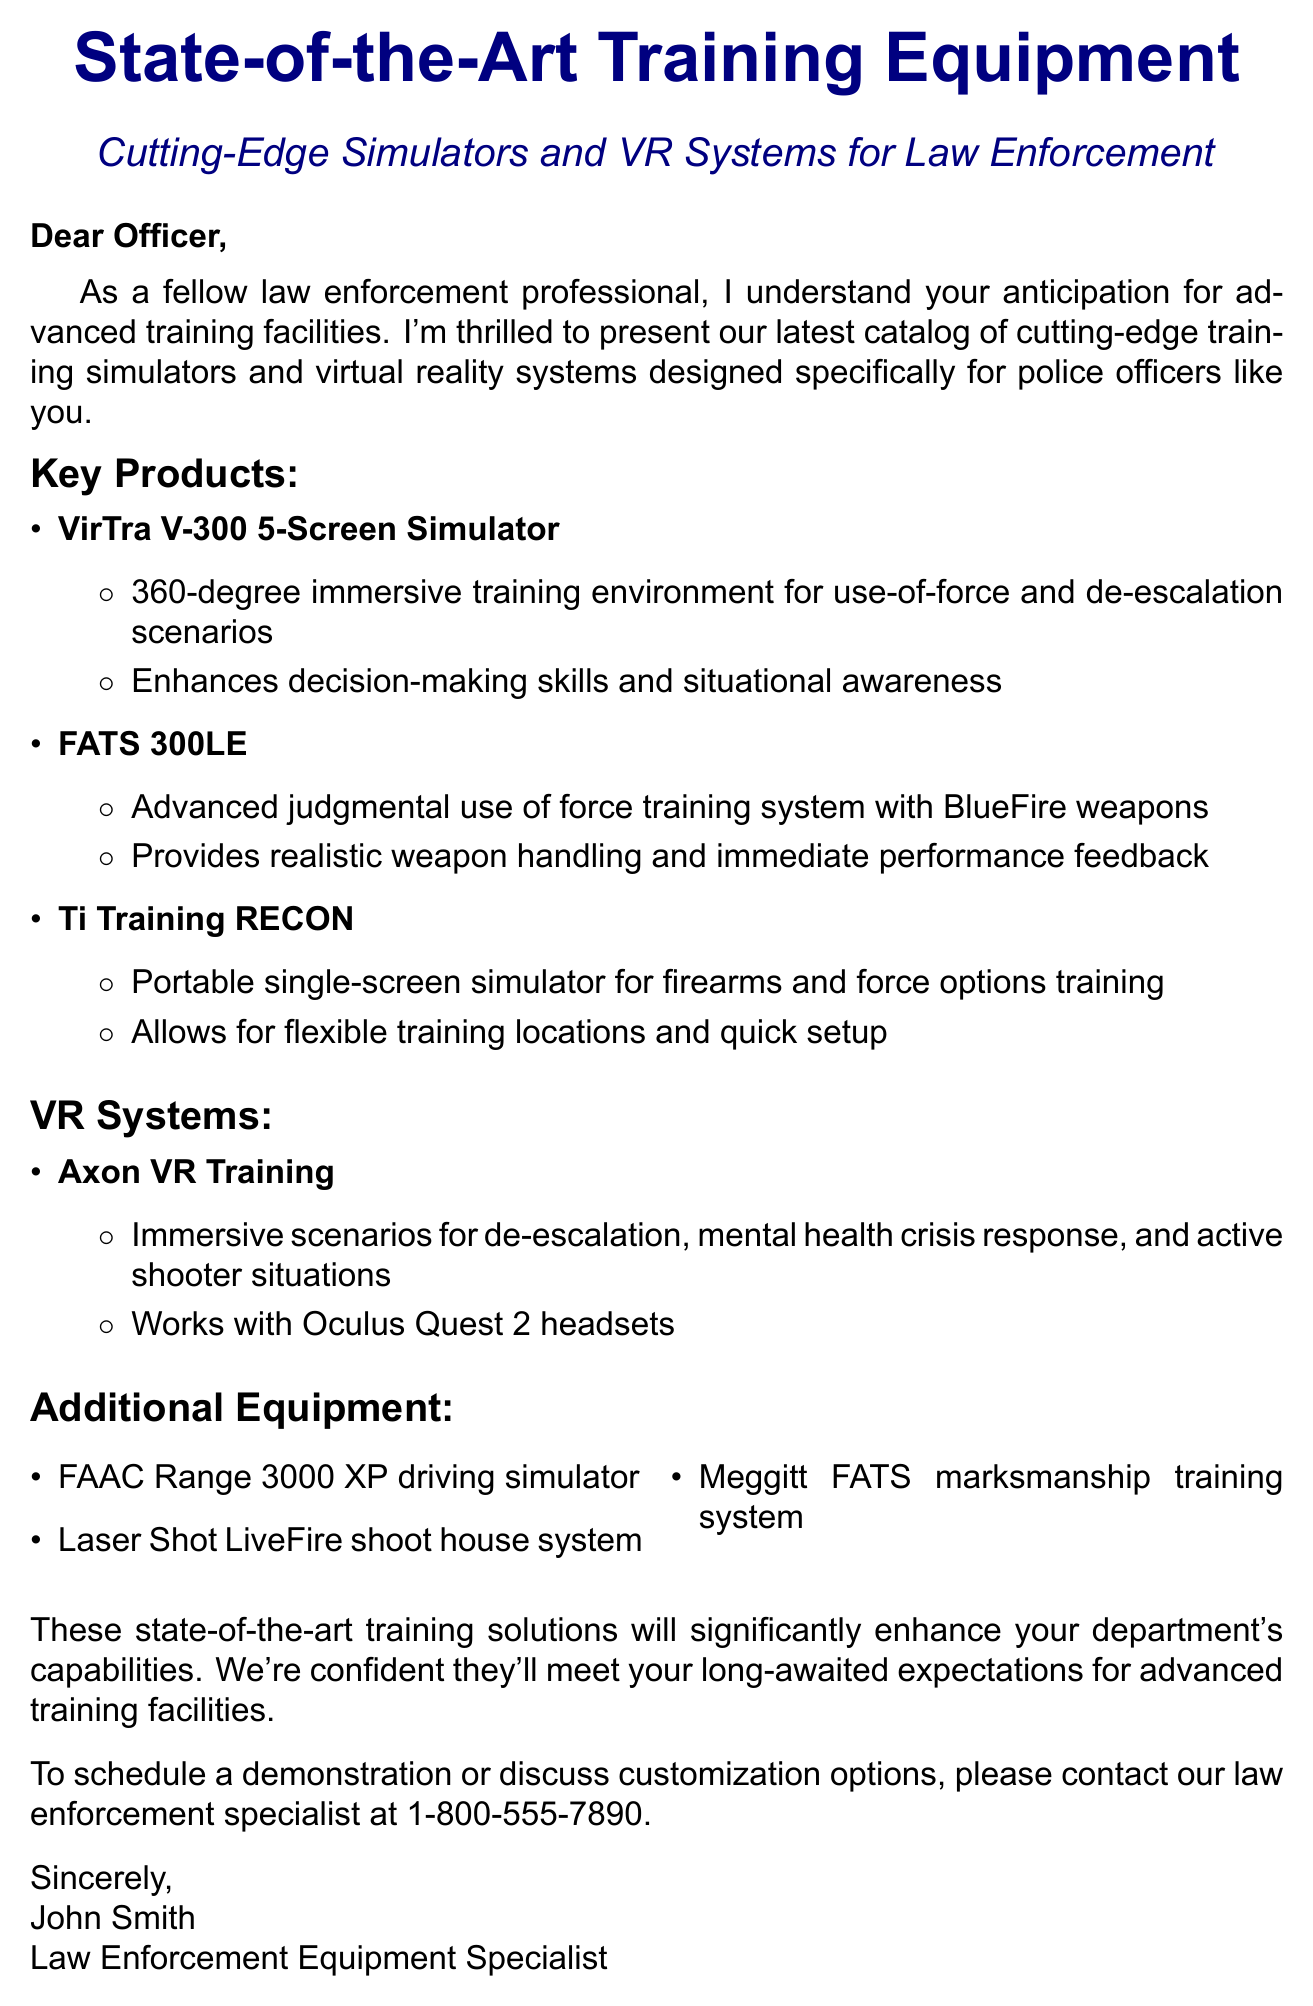What is the subject of the email? The subject of the email outlines the main topic being discussed, which is the new training equipment for law enforcement.
Answer: Exciting New Training Equipment for Law Enforcement: State-of-the-Art Simulators and VR Systems Who is the sender of the email? The sender identifies themselves at the end of the document, indicating their name and role.
Answer: John Smith What is one of the key benefits of the VirTra V-300 5-Screen Simulator? The document specifies that this simulator enhances a specific skill related to law enforcement training.
Answer: Enhances decision-making skills and situational awareness What types of scenarios does the Axon VR Training cover? The document lists various scenarios that the VR training system addresses, indicating its versatility.
Answer: de-escalation, mental health crisis response, and active shooter situations How many key products are listed in the document? The document enumerates the key products, providing a count of the items detailed in that section.
Answer: Three What is the contact number for scheduling a demonstration? The document provides a specific phone number for interested parties who want to schedule a demonstration or discuss options.
Answer: 1-800-555-7890 What format is used to classify the additional equipment? The document organizes additional items into a specific category to enhance clarity and understanding.
Answer: Bulleted list What is the greeting used in the email? The greeting sets the tone for the communication, addressing the recipient directly.
Answer: Dear Officer 